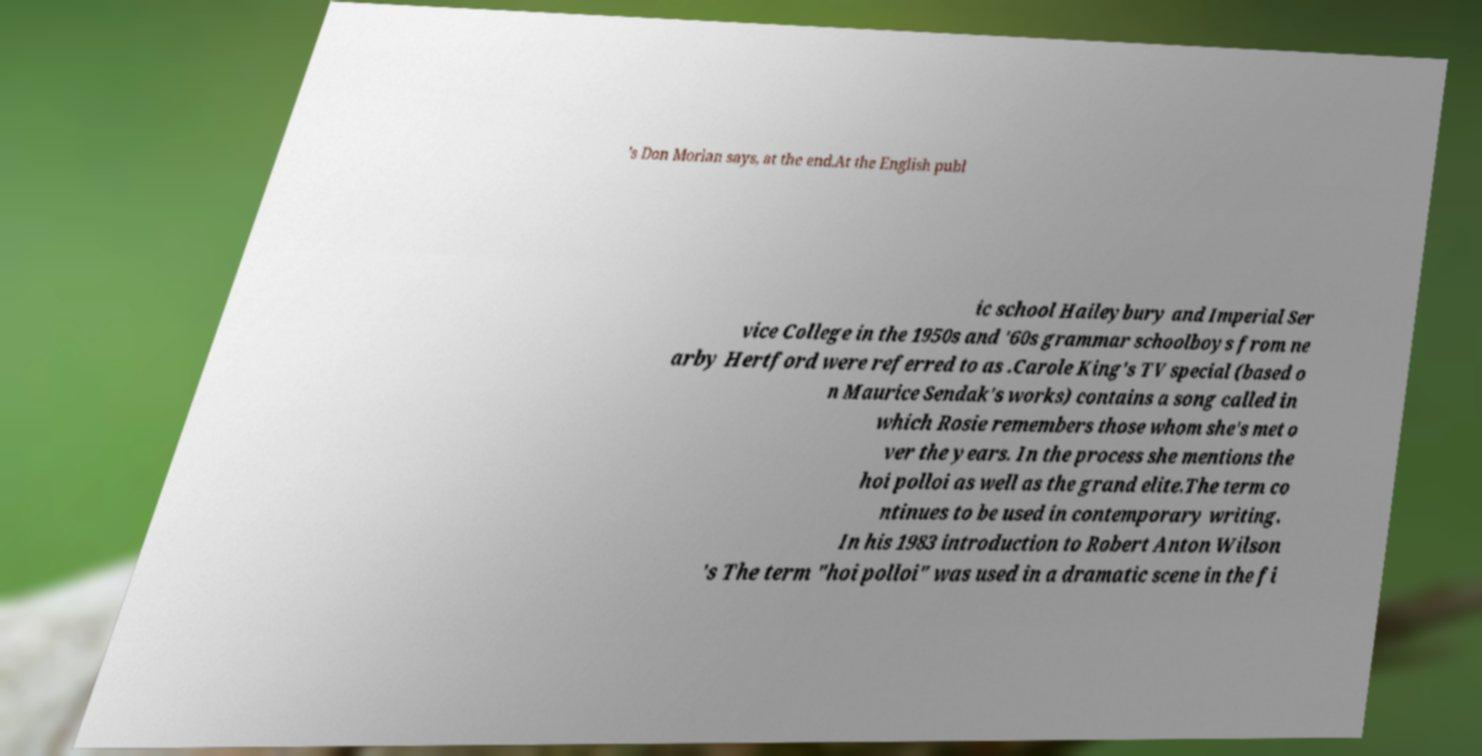For documentation purposes, I need the text within this image transcribed. Could you provide that? 's Don Morlan says, at the end.At the English publ ic school Haileybury and Imperial Ser vice College in the 1950s and '60s grammar schoolboys from ne arby Hertford were referred to as .Carole King's TV special (based o n Maurice Sendak's works) contains a song called in which Rosie remembers those whom she's met o ver the years. In the process she mentions the hoi polloi as well as the grand elite.The term co ntinues to be used in contemporary writing. In his 1983 introduction to Robert Anton Wilson 's The term "hoi polloi" was used in a dramatic scene in the fi 